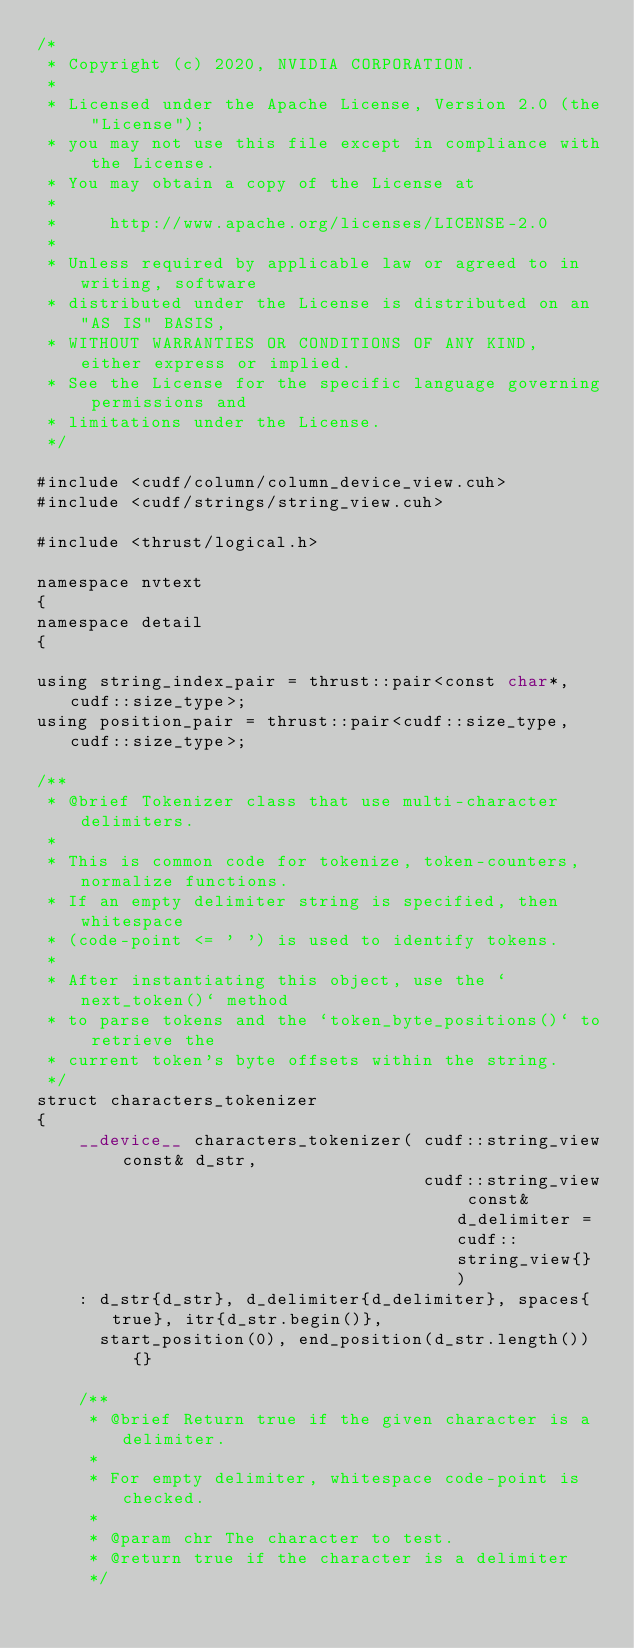Convert code to text. <code><loc_0><loc_0><loc_500><loc_500><_Cuda_>/*
 * Copyright (c) 2020, NVIDIA CORPORATION.
 *
 * Licensed under the Apache License, Version 2.0 (the "License");
 * you may not use this file except in compliance with the License.
 * You may obtain a copy of the License at
 *
 *     http://www.apache.org/licenses/LICENSE-2.0
 *
 * Unless required by applicable law or agreed to in writing, software
 * distributed under the License is distributed on an "AS IS" BASIS,
 * WITHOUT WARRANTIES OR CONDITIONS OF ANY KIND, either express or implied.
 * See the License for the specific language governing permissions and
 * limitations under the License.
 */

#include <cudf/column/column_device_view.cuh>
#include <cudf/strings/string_view.cuh>

#include <thrust/logical.h>

namespace nvtext
{
namespace detail
{

using string_index_pair = thrust::pair<const char*,cudf::size_type>;
using position_pair = thrust::pair<cudf::size_type,cudf::size_type>;

/**
 * @brief Tokenizer class that use multi-character delimiters.
 *
 * This is common code for tokenize, token-counters, normalize functions.
 * If an empty delimiter string is specified, then whitespace
 * (code-point <= ' ') is used to identify tokens.
 *
 * After instantiating this object, use the `next_token()` method
 * to parse tokens and the `token_byte_positions()` to retrieve the
 * current token's byte offsets within the string.
 */
struct characters_tokenizer
{
    __device__ characters_tokenizer( cudf::string_view const& d_str,
                                     cudf::string_view const& d_delimiter = cudf::string_view{} )
    : d_str{d_str}, d_delimiter{d_delimiter}, spaces{true}, itr{d_str.begin()},
      start_position(0), end_position(d_str.length()) {}

    /**
     * @brief Return true if the given character is a delimiter.
     *
     * For empty delimiter, whitespace code-point is checked.
     *
     * @param chr The character to test.
     * @return true if the character is a delimiter
     */</code> 